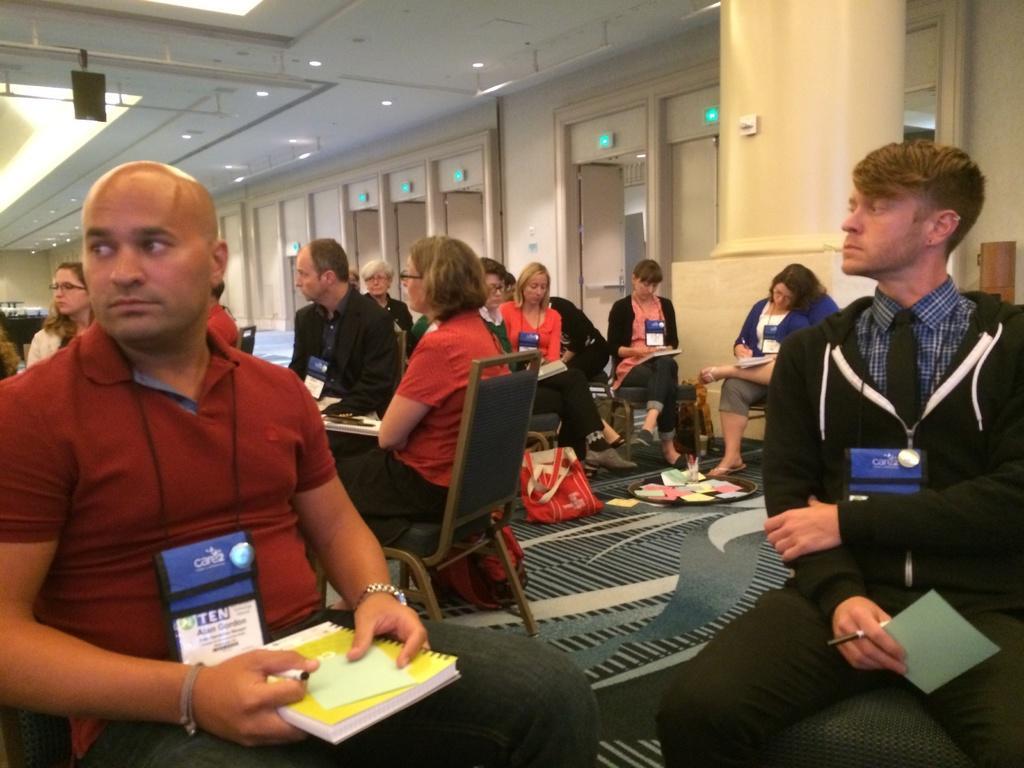Could you give a brief overview of what you see in this image? In this image I can see few people are sitting on the chairs and holding books and pens. Back I can see few doors,wall and lights. I can see bags on the floor. 